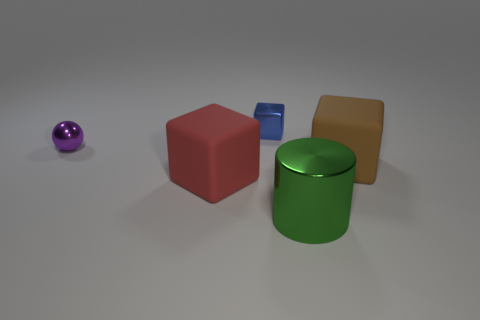What material is the purple thing?
Provide a succinct answer. Metal. Is the material of the cube that is to the right of the big shiny cylinder the same as the big green cylinder?
Give a very brief answer. No. Are there fewer large metal cylinders that are behind the ball than yellow cylinders?
Your answer should be compact. No. What is the color of the matte block that is the same size as the red thing?
Your answer should be compact. Brown. What number of small blue metal things are the same shape as the green object?
Offer a terse response. 0. What is the color of the large rubber object that is right of the green thing?
Keep it short and to the point. Brown. What number of metal things are either green cylinders or large blue blocks?
Your answer should be very brief. 1. What number of purple metal spheres are the same size as the red rubber thing?
Provide a succinct answer. 0. There is a thing that is both behind the red object and right of the blue metal cube; what color is it?
Provide a succinct answer. Brown. How many objects are either big cyan shiny balls or tiny metal things?
Give a very brief answer. 2. 